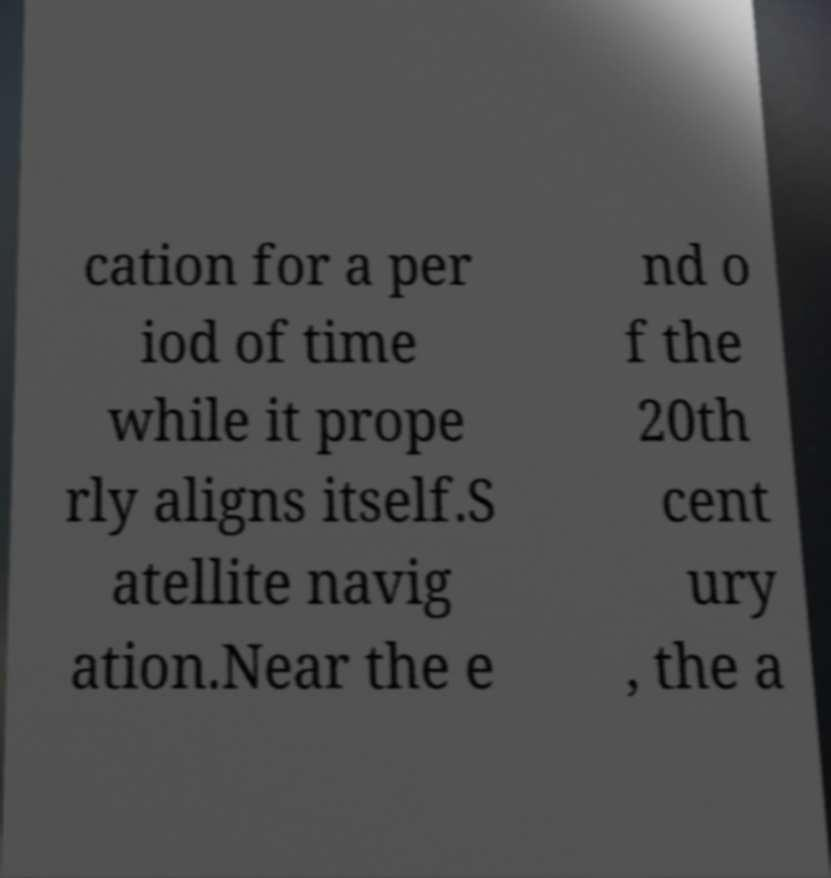Could you assist in decoding the text presented in this image and type it out clearly? cation for a per iod of time while it prope rly aligns itself.S atellite navig ation.Near the e nd o f the 20th cent ury , the a 